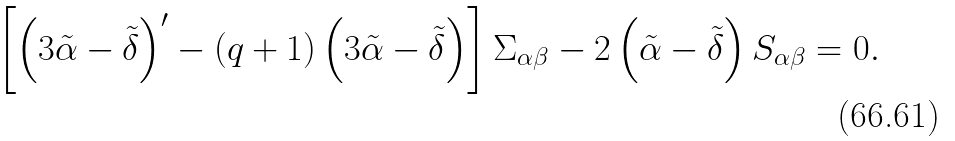<formula> <loc_0><loc_0><loc_500><loc_500>\left [ \left ( 3 \tilde { \alpha } - \tilde { \delta } \right ) ^ { \prime } - \left ( q + 1 \right ) \left ( 3 \tilde { \alpha } - \tilde { \delta } \right ) \right ] \Sigma _ { \alpha \beta } - 2 \left ( \tilde { \alpha } - \tilde { \delta } \right ) S _ { \alpha \beta } = 0 .</formula> 